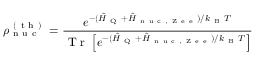<formula> <loc_0><loc_0><loc_500><loc_500>\rho _ { n u c } ^ { ( t h ) } = \frac { e ^ { - ( \hat { H } _ { Q } + \hat { H } _ { n u c , Z e e } ) / k _ { B } T } } { T r \left [ e ^ { - ( \hat { H } _ { Q } + \hat { H } _ { n u c , Z e e } ) / k _ { B } T } \right ] }</formula> 